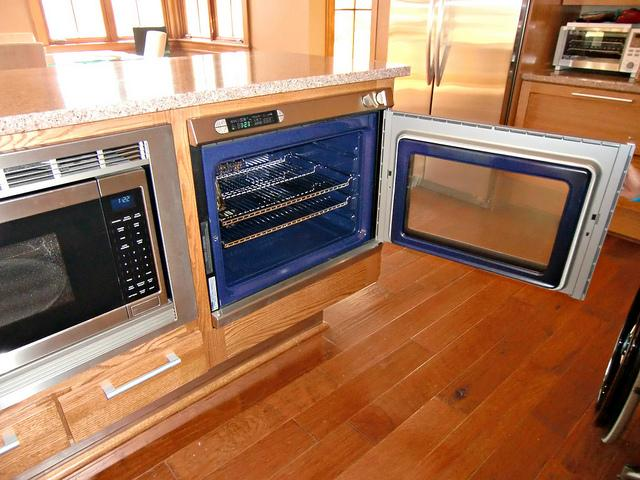What is the state of the blue item?

Choices:
A) closed
B) invisible
C) smashed
D) open open 